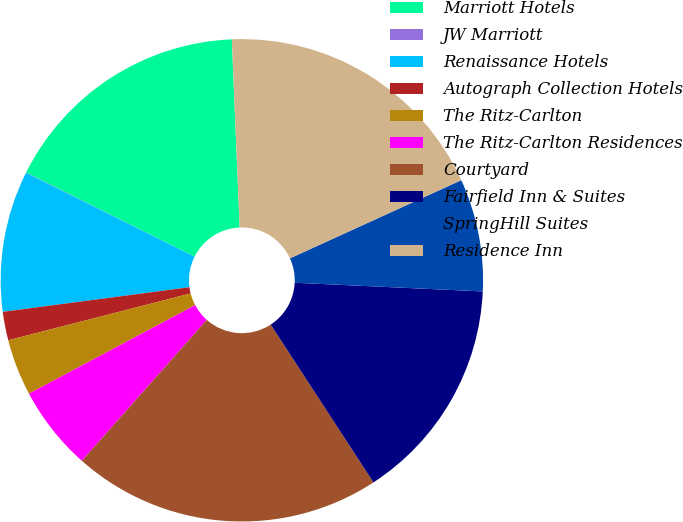Convert chart. <chart><loc_0><loc_0><loc_500><loc_500><pie_chart><fcel>Marriott Hotels<fcel>JW Marriott<fcel>Renaissance Hotels<fcel>Autograph Collection Hotels<fcel>The Ritz-Carlton<fcel>The Ritz-Carlton Residences<fcel>Courtyard<fcel>Fairfield Inn & Suites<fcel>SpringHill Suites<fcel>Residence Inn<nl><fcel>16.97%<fcel>0.02%<fcel>9.44%<fcel>1.91%<fcel>3.79%<fcel>5.67%<fcel>20.73%<fcel>15.08%<fcel>7.55%<fcel>18.85%<nl></chart> 